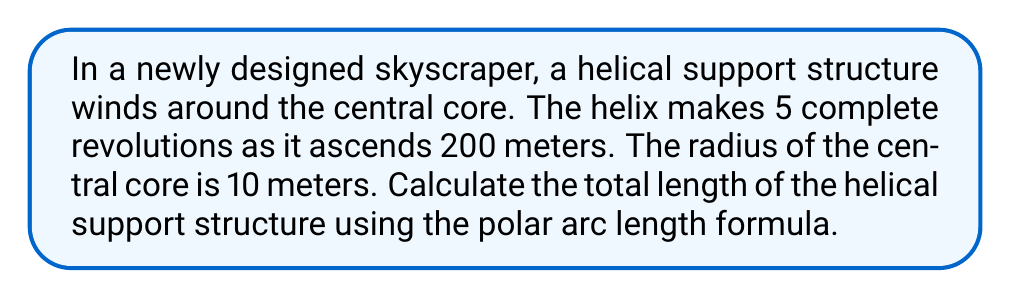What is the answer to this math problem? To solve this problem, we'll use the polar arc length formula and the parametric equations for a helix. Let's break it down step-by-step:

1) The parametric equations for a helix are:
   $x = r \cos(\theta)$
   $y = r \sin(\theta)$
   $z = c\theta$

   Where $r$ is the radius, $\theta$ is the angle in radians, and $c$ is a constant that determines the pitch of the helix.

2) We're given that the radius $r = 10$ meters and the helix makes 5 complete revolutions over 200 meters.

3) To find $c$, we use the fact that after 5 revolutions (10π radians), the height is 200 meters:
   $200 = c(10\pi)$
   $c = \frac{200}{10\pi} = \frac{20}{\pi}$

4) The polar arc length formula for a curve defined by $r = f(\theta)$ is:
   $$L = \int_a^b \sqrt{r^2 + \left(\frac{dr}{d\theta}\right)^2 + \left(\frac{dz}{d\theta}\right)^2} d\theta$$

5) In our case, $r$ is constant (10), $\frac{dr}{d\theta} = 0$, and $\frac{dz}{d\theta} = c = \frac{20}{\pi}$

6) Substituting these into the formula:
   $$L = \int_0^{10\pi} \sqrt{10^2 + 0^2 + \left(\frac{20}{\pi}\right)^2} d\theta$$

7) Simplifying:
   $$L = \int_0^{10\pi} \sqrt{100 + \frac{400}{\pi^2}} d\theta$$

8) The square root term is constant, so we can take it out of the integral:
   $$L = \sqrt{100 + \frac{400}{\pi^2}} \int_0^{10\pi} d\theta$$

9) Evaluating the integral:
   $$L = \sqrt{100 + \frac{400}{\pi^2}} [10\pi - 0]$$

10) Simplifying:
    $$L = 10\pi\sqrt{100 + \frac{400}{\pi^2}} \approx 324.3195 \text{ meters}$$
Answer: The total length of the helical support structure is approximately 324.32 meters. 